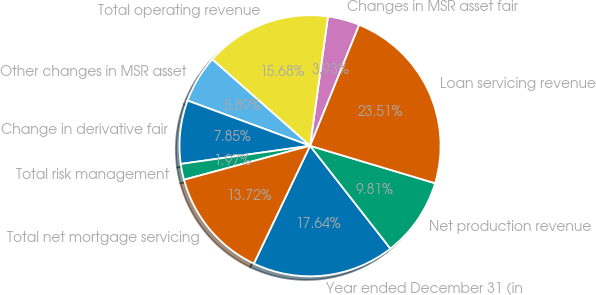Convert chart to OTSL. <chart><loc_0><loc_0><loc_500><loc_500><pie_chart><fcel>Year ended December 31 (in<fcel>Net production revenue<fcel>Loan servicing revenue<fcel>Changes in MSR asset fair<fcel>Total operating revenue<fcel>Other changes in MSR asset<fcel>Change in derivative fair<fcel>Total risk management<fcel>Total net mortgage servicing<nl><fcel>17.64%<fcel>9.81%<fcel>23.51%<fcel>3.93%<fcel>15.68%<fcel>5.89%<fcel>7.85%<fcel>1.97%<fcel>13.72%<nl></chart> 